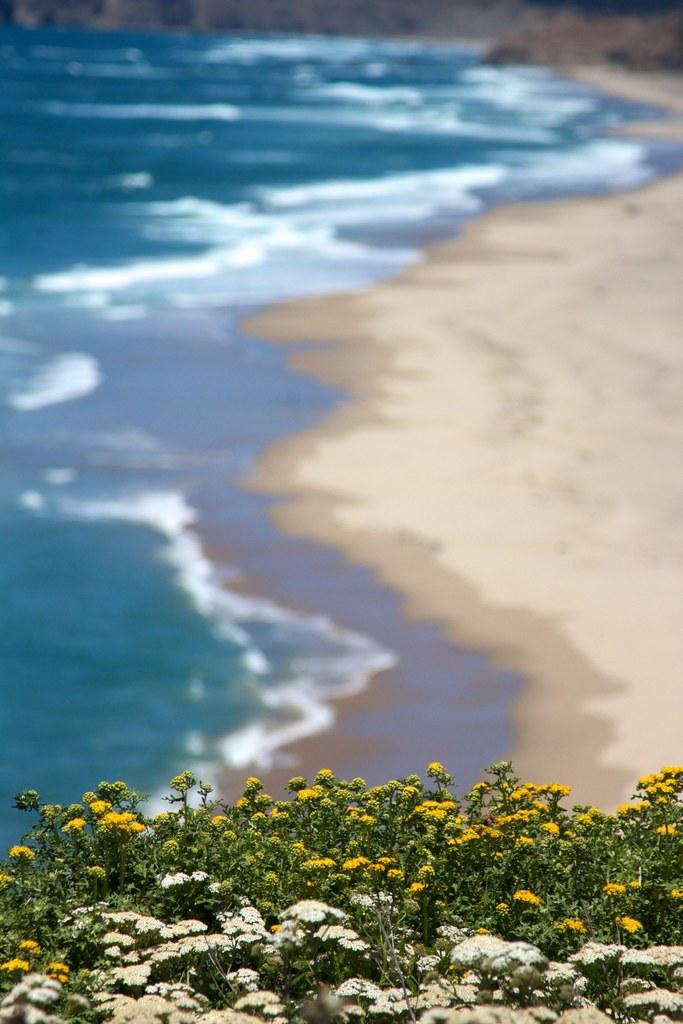What type of plants can be seen in the image? There is a group of plants with flowers in the image. What natural setting is visible in the image? There is a sea shore visible in the image, along with a water body (possibly the sea) near the shore. What type of plot is being used to grow the plants in the image? There is no information about a plot or any specific growing method in the image. --- 